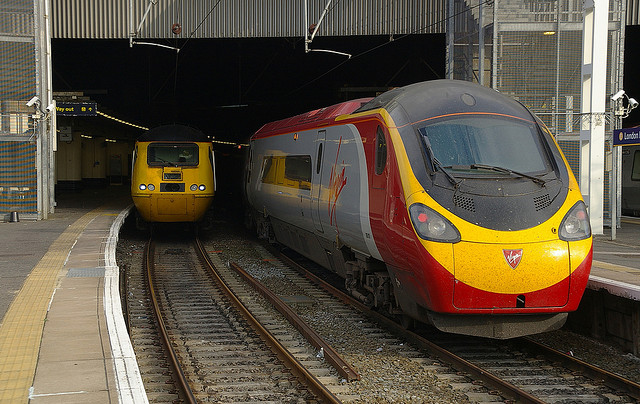How many trains are in the photo? 2 